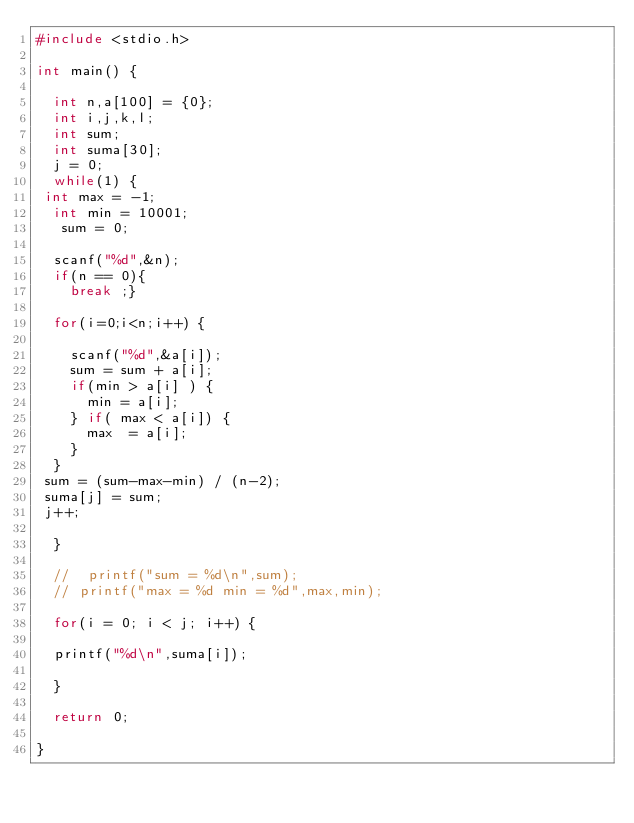<code> <loc_0><loc_0><loc_500><loc_500><_C_>#include <stdio.h>

int main() {

  int n,a[100] = {0};
  int i,j,k,l;
  int sum;
  int suma[30];
  j = 0;
  while(1) {
 int max = -1;
  int min = 10001;
   sum = 0;

  scanf("%d",&n);
  if(n == 0){
    break ;}

  for(i=0;i<n;i++) {

    scanf("%d",&a[i]);
    sum = sum + a[i];
    if(min > a[i] ) {
      min = a[i];
    } if( max < a[i]) {
      max  = a[i];
    }
  } 
 sum = (sum-max-min) / (n-2);
 suma[j] = sum;
 j++;

  }

  //  printf("sum = %d\n",sum);
  // printf("max = %d min = %d",max,min);

  for(i = 0; i < j; i++) {

  printf("%d\n",suma[i]);
  
  }

  return 0;

}</code> 